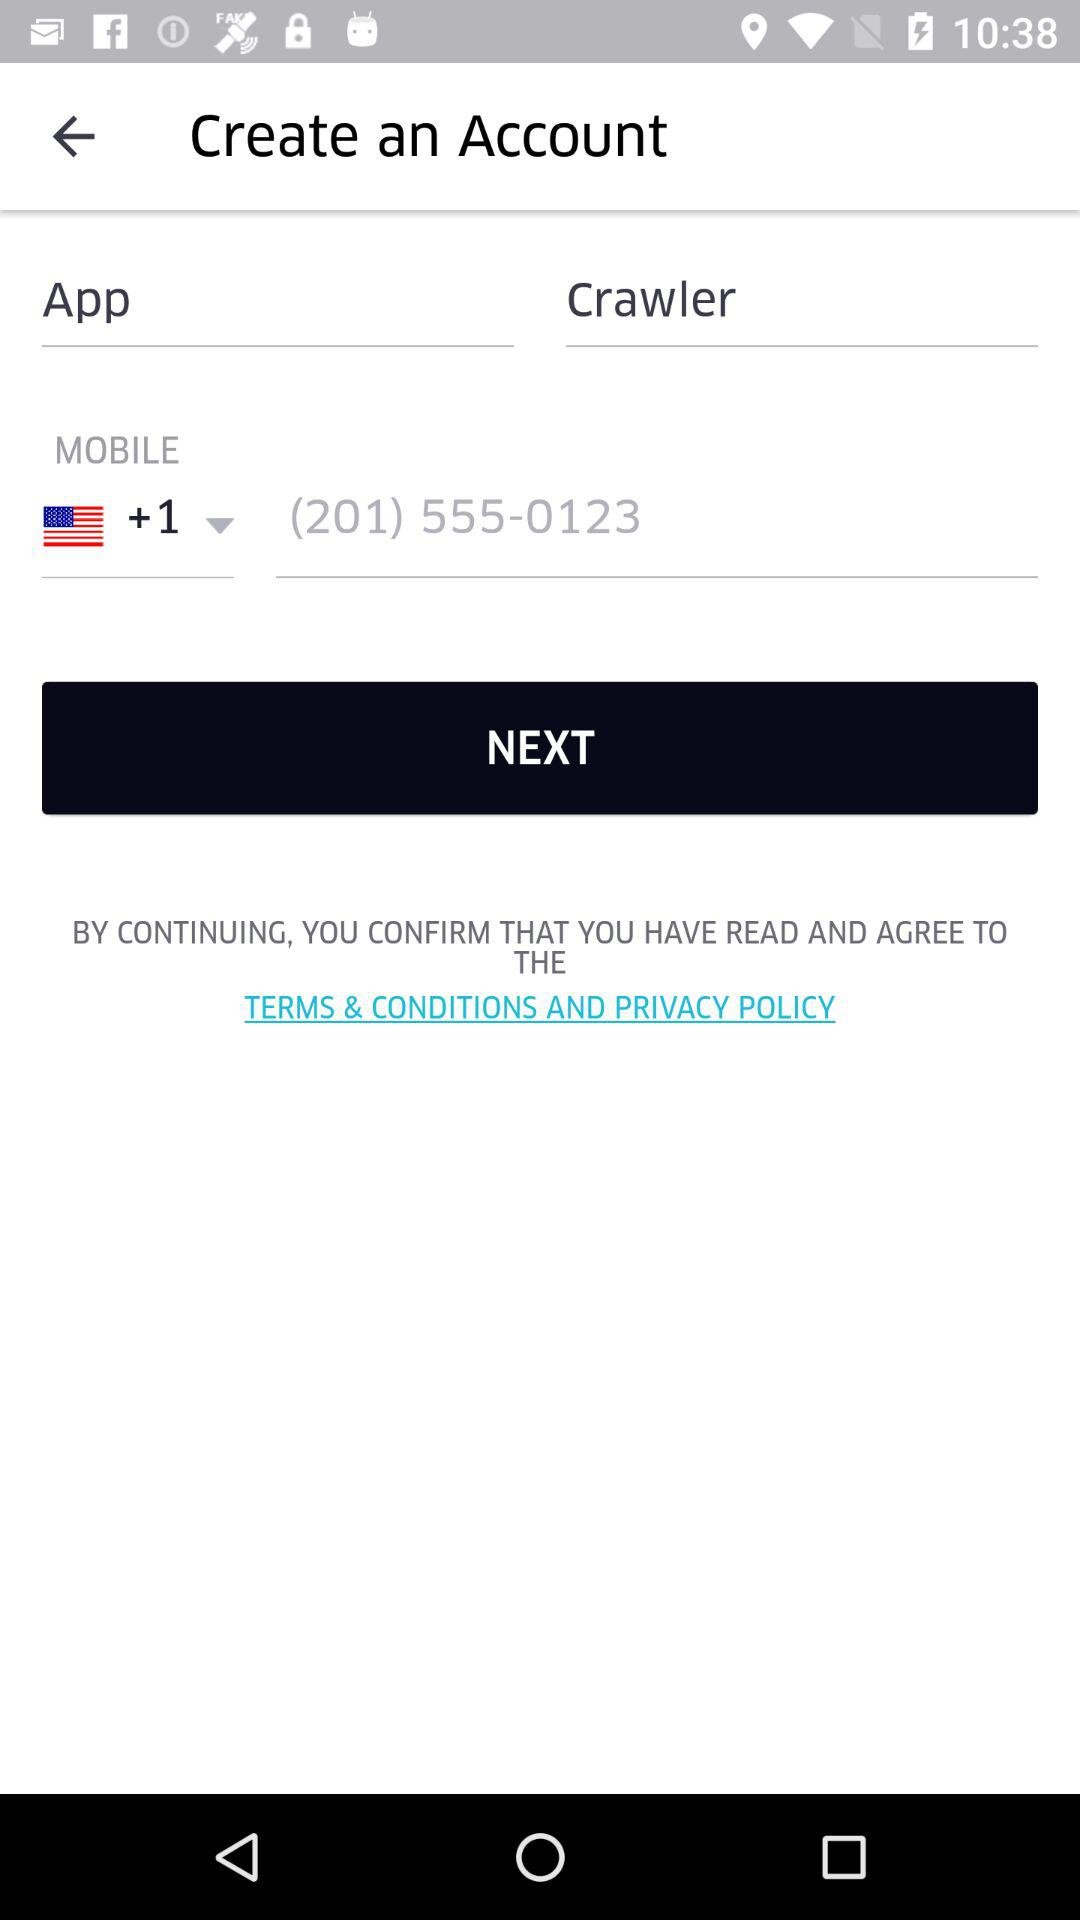What is the user name? The user name is App Crawler. 